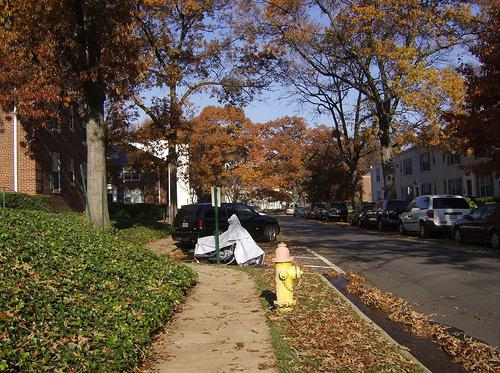What is the most likely reason that the bike is covered where it is?

Choices:
A) legal
B) protection
C) style
D) camouflage protection 